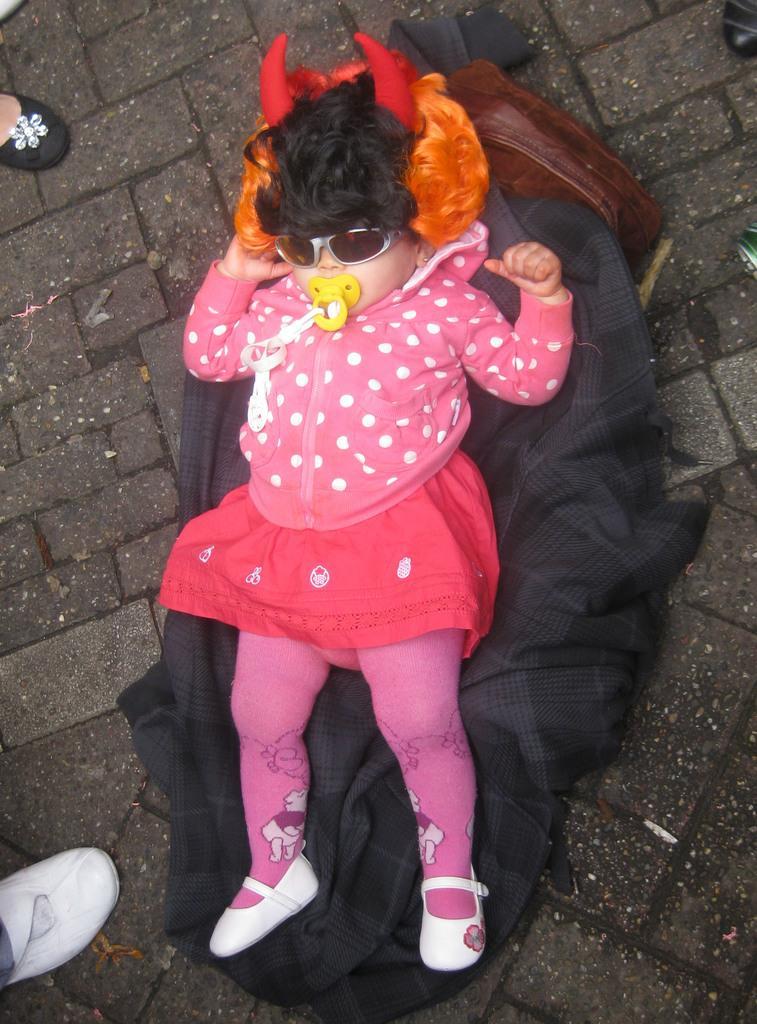Please provide a concise description of this image. In the image there is a baby girl lying on a coat and around the girl there are some people, only the feets of the people are visible in the image. 